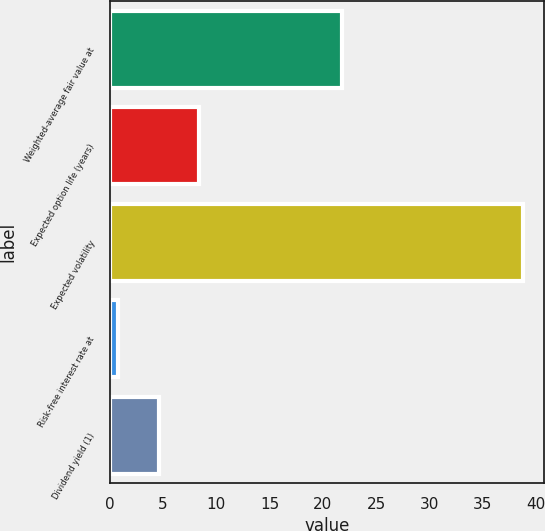Convert chart. <chart><loc_0><loc_0><loc_500><loc_500><bar_chart><fcel>Weighted-average fair value at<fcel>Expected option life (years)<fcel>Expected volatility<fcel>Risk-free interest rate at<fcel>Dividend yield (1)<nl><fcel>21.8<fcel>8.4<fcel>38.8<fcel>0.8<fcel>4.6<nl></chart> 